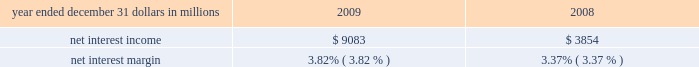Consolidated income statement review net income for 2009 was $ 2.4 billion and for 2008 was $ 914 million .
Amounts for 2009 include operating results of national city and the fourth quarter impact of a $ 687 million after-tax gain related to blackrock 2019s acquisition of bgi .
Increases in income statement comparisons to 2008 , except as noted , are primarily due to the operating results of national city .
Our consolidated income statement is presented in item 8 of this report .
Net interest income and net interest margin year ended december 31 dollars in millions 2009 2008 .
Changes in net interest income and margin result from the interaction of the volume and composition of interest-earning assets and related yields , interest-bearing liabilities and related rates paid , and noninterest-bearing sources of funding .
See statistical information 2013 analysis of year-to-year changes in net interest ( unaudited ) income and average consolidated balance sheet and net interest analysis in item 8 of this report for additional information .
Higher net interest income for 2009 compared with 2008 reflected the increase in average interest-earning assets due to national city and the improvement in the net interest margin .
The net interest margin was 3.82% ( 3.82 % ) for 2009 and 3.37% ( 3.37 % ) for 2008 .
The following factors impacted the comparison : 2022 a decrease in the rate accrued on interest-bearing liabilities of 97 basis points .
The rate accrued on interest-bearing deposits , the largest component , decreased 107 basis points .
2022 these factors were partially offset by a 45 basis point decrease in the yield on interest-earning assets .
The yield on loans , which represented the largest portion of our earning assets in 2009 , decreased 30 basis points .
2022 in addition , the impact of noninterest-bearing sources of funding decreased 7 basis points .
For comparing to the broader market , the average federal funds rate was .16% ( .16 % ) for 2009 compared with 1.94% ( 1.94 % ) for 2008 .
We expect our net interest income for 2010 will likely be modestly lower as a result of cash recoveries on purchased impaired loans in 2009 and additional run-off of higher- yielding assets , which could be mitigated by rising interest rates .
This assumes our current expectations for interest rates and economic conditions 2013 we include our current economic assumptions underlying our forward-looking statements in the cautionary statement regarding forward-looking information section of this item 7 .
Noninterest income summary noninterest income was $ 7.1 billion for 2009 and $ 2.4 billion for 2008 .
Noninterest income for 2009 included the following : 2022 the gain on blackrock/bgi transaction of $ 1.076 billion , 2022 net credit-related other-than-temporary impairments ( otti ) on debt and equity securities of $ 577 million , 2022 net gains on sales of securities of $ 550 million , 2022 gains on hedging of residential mortgage servicing rights of $ 355 million , 2022 valuation and sale income related to our commercial mortgage loans held for sale , net of hedges , of $ 107 million , 2022 gains of $ 103 million related to our blackrock ltip shares adjustment in the first quarter , and net losses on private equity and alternative investments of $ 93 million .
Noninterest income for 2008 included the following : 2022 net otti on debt and equity securities of $ 312 million , 2022 gains of $ 246 million related to our blackrock ltip shares adjustment , 2022 valuation and sale losses related to our commercial mortgage loans held for sale , net of hedges , of $ 197 million , 2022 impairment and other losses related to private equity and alternative investments of $ 180 million , 2022 income from hilliard lyons totaling $ 164 million , including the first quarter gain of $ 114 million from the sale of this business , 2022 net gains on sales of securities of $ 106 million , and 2022 a gain of $ 95 million related to the redemption of a portion of our visa class b common shares related to visa 2019s march 2008 initial public offering .
Additional analysis asset management revenue increased $ 172 million to $ 858 million in 2009 , compared with $ 686 million in 2008 .
This increase reflected improving equity markets , new business generation and a shift in assets into higher yielding equity investments during the second half of 2009 .
Assets managed totaled $ 103 billion at both december 31 , 2009 and 2008 , including the impact of national city .
The asset management group section of the business segments review section of this item 7 includes further discussion of assets under management .
Consumer services fees totaled $ 1.290 billion in 2009 compared with $ 623 million in 2008 .
Service charges on deposits totaled $ 950 million for 2009 and $ 372 million for 2008 .
Both increases were primarily driven by the impact of the national city acquisition .
Reduced consumer spending .
In percentage points , what was the change in the average federal funds rate from 2009 compared with 2008? 
Computations: (.16 - 1.94)
Answer: -1.78. 